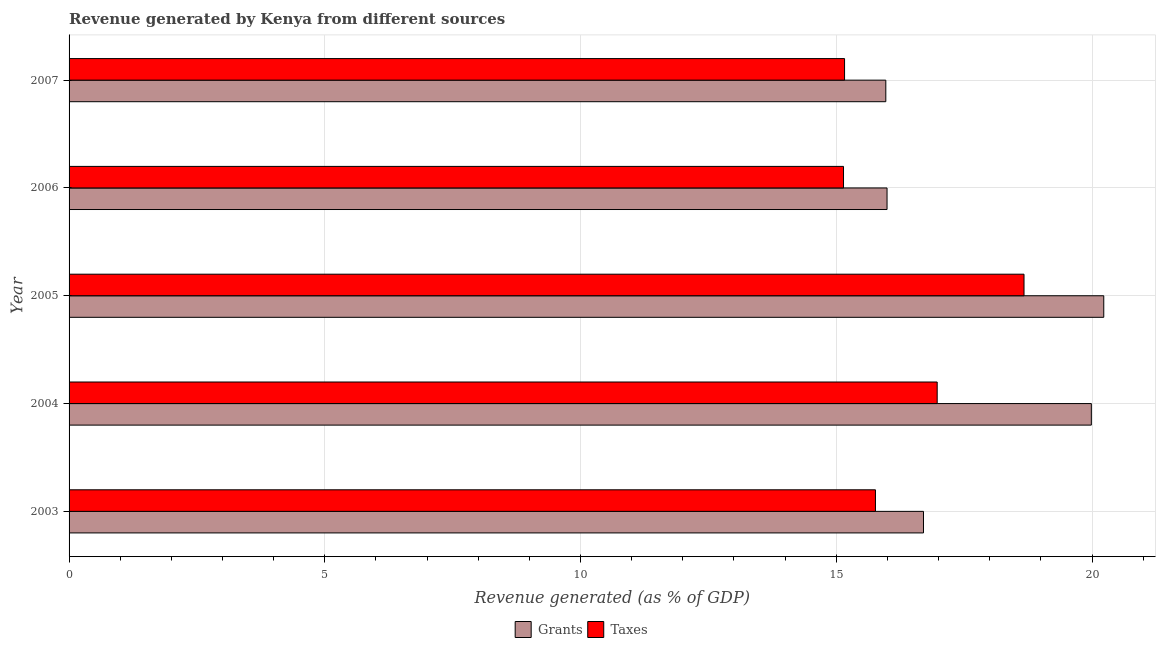Are the number of bars per tick equal to the number of legend labels?
Ensure brevity in your answer.  Yes. Are the number of bars on each tick of the Y-axis equal?
Offer a very short reply. Yes. What is the label of the 1st group of bars from the top?
Provide a short and direct response. 2007. In how many cases, is the number of bars for a given year not equal to the number of legend labels?
Your answer should be compact. 0. What is the revenue generated by grants in 2003?
Keep it short and to the point. 16.7. Across all years, what is the maximum revenue generated by taxes?
Provide a short and direct response. 18.67. Across all years, what is the minimum revenue generated by taxes?
Keep it short and to the point. 15.14. In which year was the revenue generated by taxes maximum?
Give a very brief answer. 2005. What is the total revenue generated by grants in the graph?
Your answer should be compact. 88.88. What is the difference between the revenue generated by grants in 2003 and that in 2007?
Provide a short and direct response. 0.74. What is the difference between the revenue generated by taxes in 2007 and the revenue generated by grants in 2003?
Your answer should be compact. -1.54. What is the average revenue generated by grants per year?
Make the answer very short. 17.78. In the year 2007, what is the difference between the revenue generated by grants and revenue generated by taxes?
Your response must be concise. 0.81. What is the ratio of the revenue generated by taxes in 2004 to that in 2007?
Give a very brief answer. 1.12. Is the revenue generated by grants in 2003 less than that in 2005?
Give a very brief answer. Yes. Is the difference between the revenue generated by taxes in 2005 and 2007 greater than the difference between the revenue generated by grants in 2005 and 2007?
Your response must be concise. No. What is the difference between the highest and the second highest revenue generated by taxes?
Ensure brevity in your answer.  1.7. What is the difference between the highest and the lowest revenue generated by taxes?
Your answer should be very brief. 3.53. In how many years, is the revenue generated by taxes greater than the average revenue generated by taxes taken over all years?
Ensure brevity in your answer.  2. Is the sum of the revenue generated by taxes in 2003 and 2007 greater than the maximum revenue generated by grants across all years?
Make the answer very short. Yes. What does the 1st bar from the top in 2006 represents?
Your response must be concise. Taxes. What does the 1st bar from the bottom in 2005 represents?
Your answer should be compact. Grants. How many bars are there?
Give a very brief answer. 10. Are all the bars in the graph horizontal?
Your answer should be compact. Yes. What is the difference between two consecutive major ticks on the X-axis?
Your response must be concise. 5. How many legend labels are there?
Your answer should be compact. 2. What is the title of the graph?
Your answer should be compact. Revenue generated by Kenya from different sources. What is the label or title of the X-axis?
Keep it short and to the point. Revenue generated (as % of GDP). What is the label or title of the Y-axis?
Provide a short and direct response. Year. What is the Revenue generated (as % of GDP) of Grants in 2003?
Your response must be concise. 16.7. What is the Revenue generated (as % of GDP) in Taxes in 2003?
Ensure brevity in your answer.  15.77. What is the Revenue generated (as % of GDP) of Grants in 2004?
Offer a terse response. 19.99. What is the Revenue generated (as % of GDP) in Taxes in 2004?
Provide a short and direct response. 16.97. What is the Revenue generated (as % of GDP) of Grants in 2005?
Keep it short and to the point. 20.23. What is the Revenue generated (as % of GDP) of Taxes in 2005?
Offer a very short reply. 18.67. What is the Revenue generated (as % of GDP) in Grants in 2006?
Give a very brief answer. 15.99. What is the Revenue generated (as % of GDP) in Taxes in 2006?
Offer a terse response. 15.14. What is the Revenue generated (as % of GDP) of Grants in 2007?
Provide a succinct answer. 15.97. What is the Revenue generated (as % of GDP) of Taxes in 2007?
Your answer should be very brief. 15.16. Across all years, what is the maximum Revenue generated (as % of GDP) of Grants?
Your response must be concise. 20.23. Across all years, what is the maximum Revenue generated (as % of GDP) of Taxes?
Offer a very short reply. 18.67. Across all years, what is the minimum Revenue generated (as % of GDP) of Grants?
Your response must be concise. 15.97. Across all years, what is the minimum Revenue generated (as % of GDP) of Taxes?
Give a very brief answer. 15.14. What is the total Revenue generated (as % of GDP) in Grants in the graph?
Give a very brief answer. 88.88. What is the total Revenue generated (as % of GDP) of Taxes in the graph?
Provide a succinct answer. 81.71. What is the difference between the Revenue generated (as % of GDP) in Grants in 2003 and that in 2004?
Offer a terse response. -3.28. What is the difference between the Revenue generated (as % of GDP) of Taxes in 2003 and that in 2004?
Ensure brevity in your answer.  -1.21. What is the difference between the Revenue generated (as % of GDP) of Grants in 2003 and that in 2005?
Your answer should be very brief. -3.52. What is the difference between the Revenue generated (as % of GDP) in Taxes in 2003 and that in 2005?
Offer a very short reply. -2.9. What is the difference between the Revenue generated (as % of GDP) in Grants in 2003 and that in 2006?
Your response must be concise. 0.71. What is the difference between the Revenue generated (as % of GDP) of Taxes in 2003 and that in 2006?
Keep it short and to the point. 0.62. What is the difference between the Revenue generated (as % of GDP) of Grants in 2003 and that in 2007?
Keep it short and to the point. 0.74. What is the difference between the Revenue generated (as % of GDP) in Taxes in 2003 and that in 2007?
Your answer should be very brief. 0.6. What is the difference between the Revenue generated (as % of GDP) of Grants in 2004 and that in 2005?
Your answer should be very brief. -0.24. What is the difference between the Revenue generated (as % of GDP) in Taxes in 2004 and that in 2005?
Ensure brevity in your answer.  -1.7. What is the difference between the Revenue generated (as % of GDP) of Grants in 2004 and that in 2006?
Your answer should be very brief. 3.99. What is the difference between the Revenue generated (as % of GDP) of Taxes in 2004 and that in 2006?
Keep it short and to the point. 1.83. What is the difference between the Revenue generated (as % of GDP) in Grants in 2004 and that in 2007?
Your answer should be compact. 4.02. What is the difference between the Revenue generated (as % of GDP) in Taxes in 2004 and that in 2007?
Give a very brief answer. 1.81. What is the difference between the Revenue generated (as % of GDP) in Grants in 2005 and that in 2006?
Offer a very short reply. 4.24. What is the difference between the Revenue generated (as % of GDP) in Taxes in 2005 and that in 2006?
Offer a terse response. 3.53. What is the difference between the Revenue generated (as % of GDP) in Grants in 2005 and that in 2007?
Your answer should be very brief. 4.26. What is the difference between the Revenue generated (as % of GDP) in Taxes in 2005 and that in 2007?
Your answer should be very brief. 3.51. What is the difference between the Revenue generated (as % of GDP) in Grants in 2006 and that in 2007?
Your answer should be compact. 0.02. What is the difference between the Revenue generated (as % of GDP) in Taxes in 2006 and that in 2007?
Keep it short and to the point. -0.02. What is the difference between the Revenue generated (as % of GDP) of Grants in 2003 and the Revenue generated (as % of GDP) of Taxes in 2004?
Offer a terse response. -0.27. What is the difference between the Revenue generated (as % of GDP) in Grants in 2003 and the Revenue generated (as % of GDP) in Taxes in 2005?
Ensure brevity in your answer.  -1.97. What is the difference between the Revenue generated (as % of GDP) in Grants in 2003 and the Revenue generated (as % of GDP) in Taxes in 2006?
Your answer should be very brief. 1.56. What is the difference between the Revenue generated (as % of GDP) of Grants in 2003 and the Revenue generated (as % of GDP) of Taxes in 2007?
Provide a short and direct response. 1.54. What is the difference between the Revenue generated (as % of GDP) of Grants in 2004 and the Revenue generated (as % of GDP) of Taxes in 2005?
Give a very brief answer. 1.32. What is the difference between the Revenue generated (as % of GDP) of Grants in 2004 and the Revenue generated (as % of GDP) of Taxes in 2006?
Your answer should be very brief. 4.85. What is the difference between the Revenue generated (as % of GDP) in Grants in 2004 and the Revenue generated (as % of GDP) in Taxes in 2007?
Your response must be concise. 4.82. What is the difference between the Revenue generated (as % of GDP) in Grants in 2005 and the Revenue generated (as % of GDP) in Taxes in 2006?
Provide a short and direct response. 5.09. What is the difference between the Revenue generated (as % of GDP) of Grants in 2005 and the Revenue generated (as % of GDP) of Taxes in 2007?
Provide a succinct answer. 5.07. What is the difference between the Revenue generated (as % of GDP) in Grants in 2006 and the Revenue generated (as % of GDP) in Taxes in 2007?
Offer a terse response. 0.83. What is the average Revenue generated (as % of GDP) in Grants per year?
Ensure brevity in your answer.  17.78. What is the average Revenue generated (as % of GDP) in Taxes per year?
Offer a terse response. 16.34. In the year 2003, what is the difference between the Revenue generated (as % of GDP) of Grants and Revenue generated (as % of GDP) of Taxes?
Ensure brevity in your answer.  0.94. In the year 2004, what is the difference between the Revenue generated (as % of GDP) of Grants and Revenue generated (as % of GDP) of Taxes?
Make the answer very short. 3.01. In the year 2005, what is the difference between the Revenue generated (as % of GDP) in Grants and Revenue generated (as % of GDP) in Taxes?
Provide a short and direct response. 1.56. In the year 2006, what is the difference between the Revenue generated (as % of GDP) in Grants and Revenue generated (as % of GDP) in Taxes?
Provide a short and direct response. 0.85. In the year 2007, what is the difference between the Revenue generated (as % of GDP) of Grants and Revenue generated (as % of GDP) of Taxes?
Offer a very short reply. 0.81. What is the ratio of the Revenue generated (as % of GDP) of Grants in 2003 to that in 2004?
Your answer should be compact. 0.84. What is the ratio of the Revenue generated (as % of GDP) of Taxes in 2003 to that in 2004?
Your answer should be very brief. 0.93. What is the ratio of the Revenue generated (as % of GDP) in Grants in 2003 to that in 2005?
Offer a terse response. 0.83. What is the ratio of the Revenue generated (as % of GDP) of Taxes in 2003 to that in 2005?
Your response must be concise. 0.84. What is the ratio of the Revenue generated (as % of GDP) in Grants in 2003 to that in 2006?
Your answer should be compact. 1.04. What is the ratio of the Revenue generated (as % of GDP) of Taxes in 2003 to that in 2006?
Offer a terse response. 1.04. What is the ratio of the Revenue generated (as % of GDP) of Grants in 2003 to that in 2007?
Ensure brevity in your answer.  1.05. What is the ratio of the Revenue generated (as % of GDP) of Taxes in 2003 to that in 2007?
Provide a succinct answer. 1.04. What is the ratio of the Revenue generated (as % of GDP) of Grants in 2004 to that in 2006?
Give a very brief answer. 1.25. What is the ratio of the Revenue generated (as % of GDP) of Taxes in 2004 to that in 2006?
Provide a short and direct response. 1.12. What is the ratio of the Revenue generated (as % of GDP) in Grants in 2004 to that in 2007?
Ensure brevity in your answer.  1.25. What is the ratio of the Revenue generated (as % of GDP) of Taxes in 2004 to that in 2007?
Your answer should be very brief. 1.12. What is the ratio of the Revenue generated (as % of GDP) of Grants in 2005 to that in 2006?
Offer a terse response. 1.26. What is the ratio of the Revenue generated (as % of GDP) in Taxes in 2005 to that in 2006?
Offer a very short reply. 1.23. What is the ratio of the Revenue generated (as % of GDP) in Grants in 2005 to that in 2007?
Make the answer very short. 1.27. What is the ratio of the Revenue generated (as % of GDP) of Taxes in 2005 to that in 2007?
Your answer should be very brief. 1.23. What is the ratio of the Revenue generated (as % of GDP) in Grants in 2006 to that in 2007?
Give a very brief answer. 1. What is the difference between the highest and the second highest Revenue generated (as % of GDP) of Grants?
Your response must be concise. 0.24. What is the difference between the highest and the second highest Revenue generated (as % of GDP) of Taxes?
Your response must be concise. 1.7. What is the difference between the highest and the lowest Revenue generated (as % of GDP) of Grants?
Your response must be concise. 4.26. What is the difference between the highest and the lowest Revenue generated (as % of GDP) in Taxes?
Offer a terse response. 3.53. 